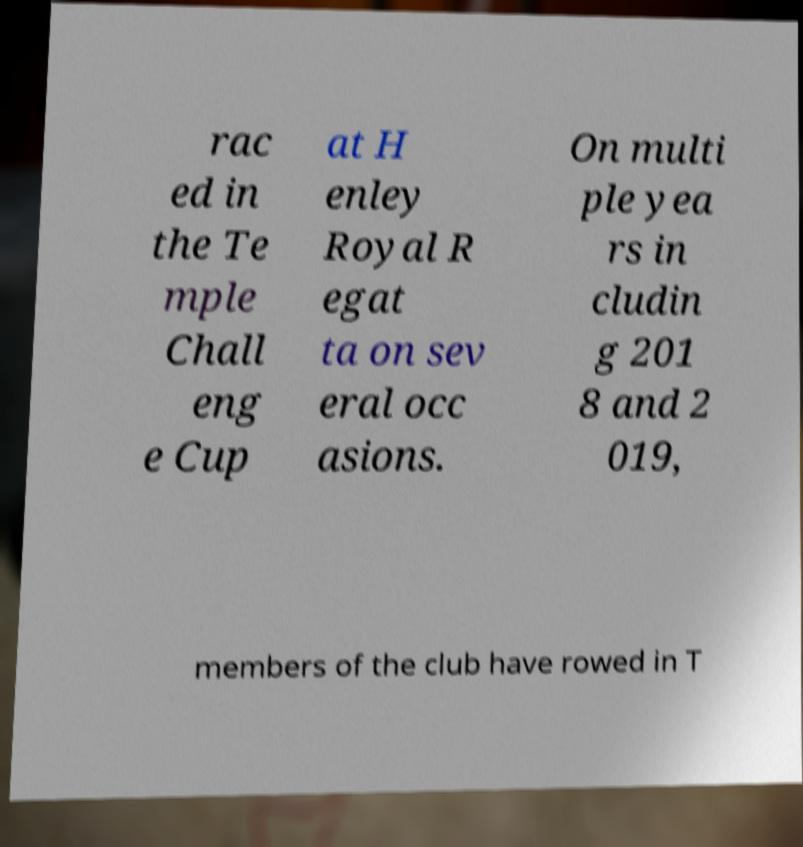There's text embedded in this image that I need extracted. Can you transcribe it verbatim? rac ed in the Te mple Chall eng e Cup at H enley Royal R egat ta on sev eral occ asions. On multi ple yea rs in cludin g 201 8 and 2 019, members of the club have rowed in T 